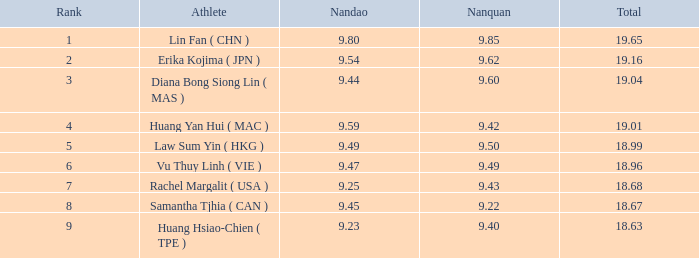Which Nanquan has a Nandao smaller than 9.44, and a Rank smaller than 9, and a Total larger than 18.68? None. 